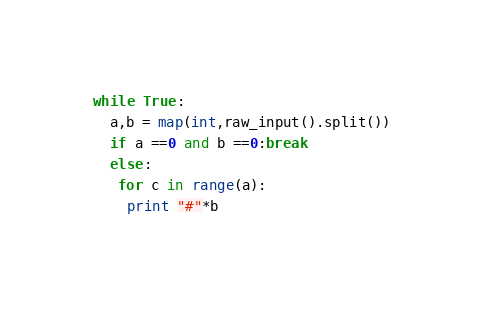<code> <loc_0><loc_0><loc_500><loc_500><_Python_>while True:
  a,b = map(int,raw_input().split())
  if a ==0 and b ==0:break
  else:
   for c in range(a):
    print "#"*b</code> 